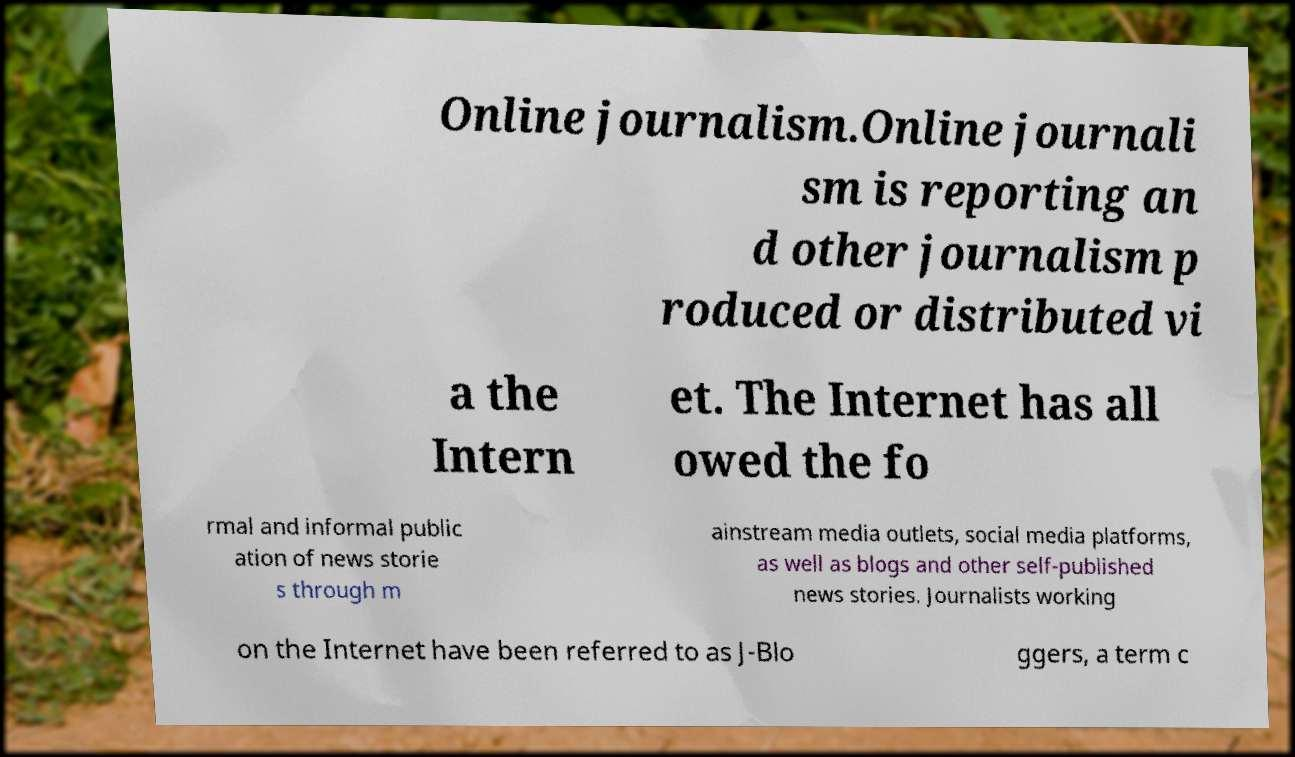I need the written content from this picture converted into text. Can you do that? Online journalism.Online journali sm is reporting an d other journalism p roduced or distributed vi a the Intern et. The Internet has all owed the fo rmal and informal public ation of news storie s through m ainstream media outlets, social media platforms, as well as blogs and other self-published news stories. Journalists working on the Internet have been referred to as J-Blo ggers, a term c 